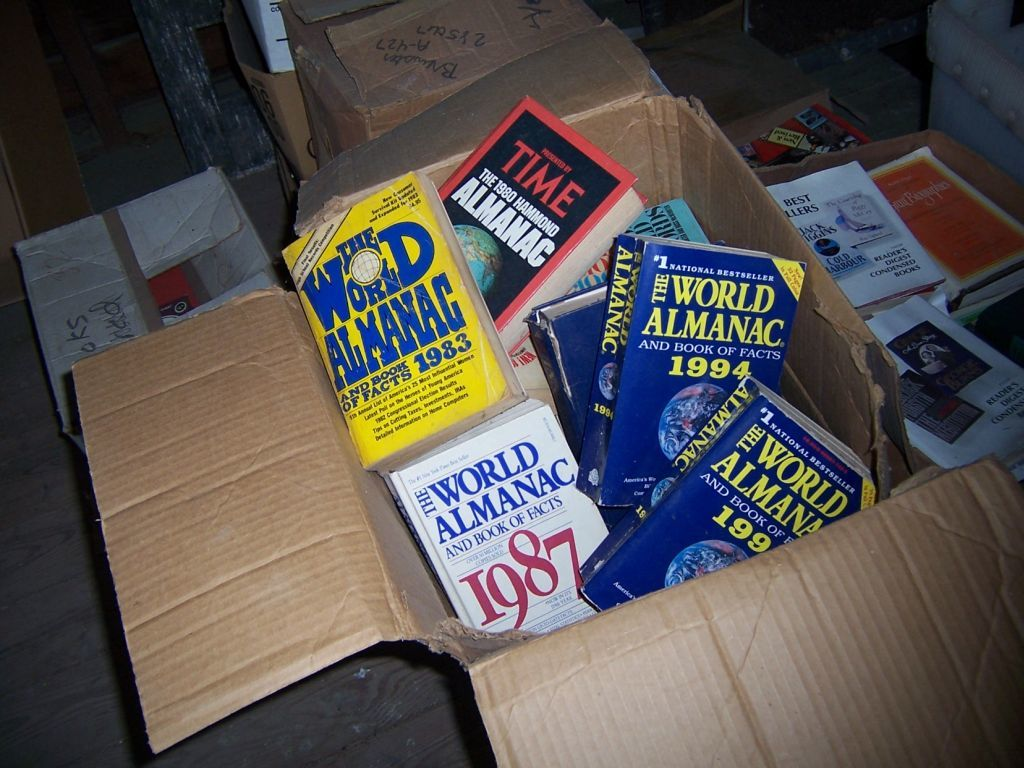Provide a one-sentence caption for the provided image. An assortment of well-thumbed World Almanac books from various years, including editions from 1983, 1987, 1994, and others, piled carelessly in a worn cardboard box, hinting at a rich history of use and storage. 